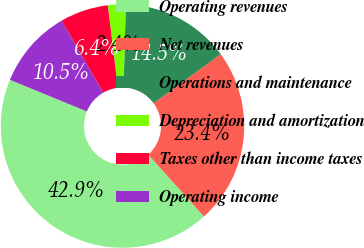Convert chart to OTSL. <chart><loc_0><loc_0><loc_500><loc_500><pie_chart><fcel>Operating revenues<fcel>Net revenues<fcel>Operations and maintenance<fcel>Depreciation and amortization<fcel>Taxes other than income taxes<fcel>Operating income<nl><fcel>42.86%<fcel>23.4%<fcel>14.51%<fcel>2.36%<fcel>6.41%<fcel>10.46%<nl></chart> 